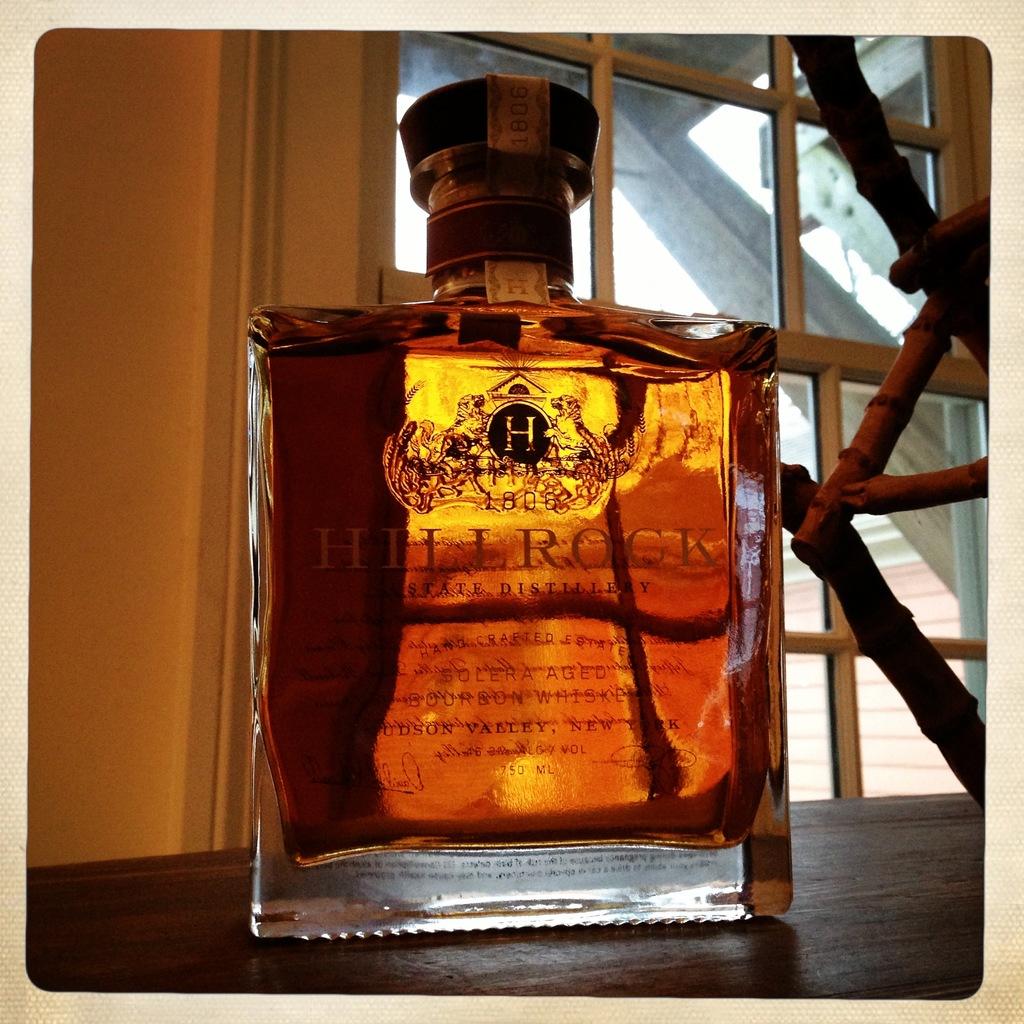What is the initial in the black circle on the bottle?
Give a very brief answer. H. 